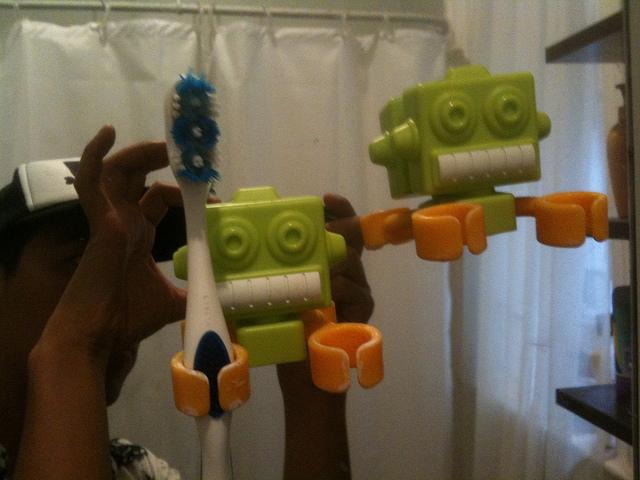How many "teeth" does each robot have?
Answer briefly. 6. How many toothbrushes are present?
Quick response, please. 1. What kind of holder is shown?
Quick response, please. Toothbrush. 